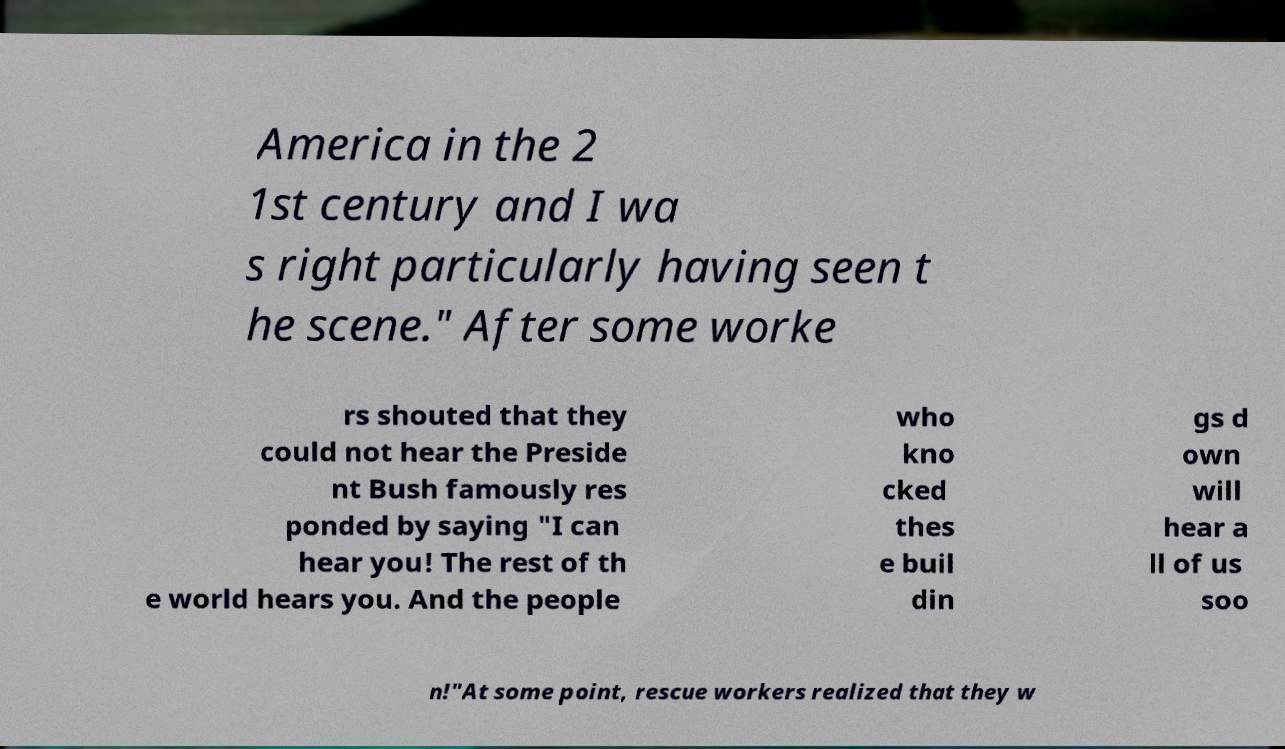Could you assist in decoding the text presented in this image and type it out clearly? America in the 2 1st century and I wa s right particularly having seen t he scene." After some worke rs shouted that they could not hear the Preside nt Bush famously res ponded by saying "I can hear you! The rest of th e world hears you. And the people who kno cked thes e buil din gs d own will hear a ll of us soo n!"At some point, rescue workers realized that they w 